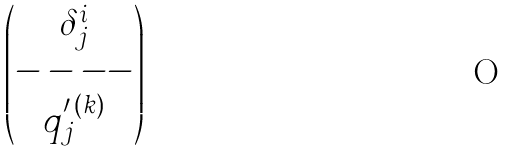Convert formula to latex. <formula><loc_0><loc_0><loc_500><loc_500>\begin{pmatrix} \delta ^ { i } _ { j } \\ - - - - \\ q _ { j } ^ { \prime \, ( k ) } \end{pmatrix}</formula> 